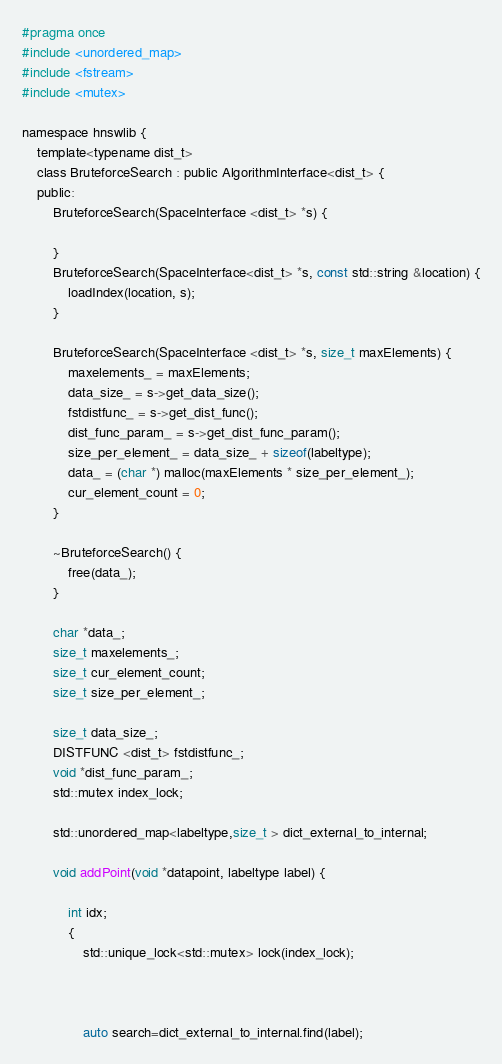<code> <loc_0><loc_0><loc_500><loc_500><_C_>#pragma once
#include <unordered_map>
#include <fstream>
#include <mutex>

namespace hnswlib {
    template<typename dist_t>
    class BruteforceSearch : public AlgorithmInterface<dist_t> {
    public:
        BruteforceSearch(SpaceInterface <dist_t> *s) {

        }
        BruteforceSearch(SpaceInterface<dist_t> *s, const std::string &location) {
            loadIndex(location, s);
        }

        BruteforceSearch(SpaceInterface <dist_t> *s, size_t maxElements) {
            maxelements_ = maxElements;
            data_size_ = s->get_data_size();
            fstdistfunc_ = s->get_dist_func();
            dist_func_param_ = s->get_dist_func_param();
            size_per_element_ = data_size_ + sizeof(labeltype);
            data_ = (char *) malloc(maxElements * size_per_element_);
            cur_element_count = 0;
        }

        ~BruteforceSearch() {
            free(data_);
        }

        char *data_;
        size_t maxelements_;
        size_t cur_element_count;
        size_t size_per_element_;

        size_t data_size_;
        DISTFUNC <dist_t> fstdistfunc_;
        void *dist_func_param_;
        std::mutex index_lock;

        std::unordered_map<labeltype,size_t > dict_external_to_internal;

        void addPoint(void *datapoint, labeltype label) {

            int idx;
            {
                std::unique_lock<std::mutex> lock(index_lock);



                auto search=dict_external_to_internal.find(label);</code> 